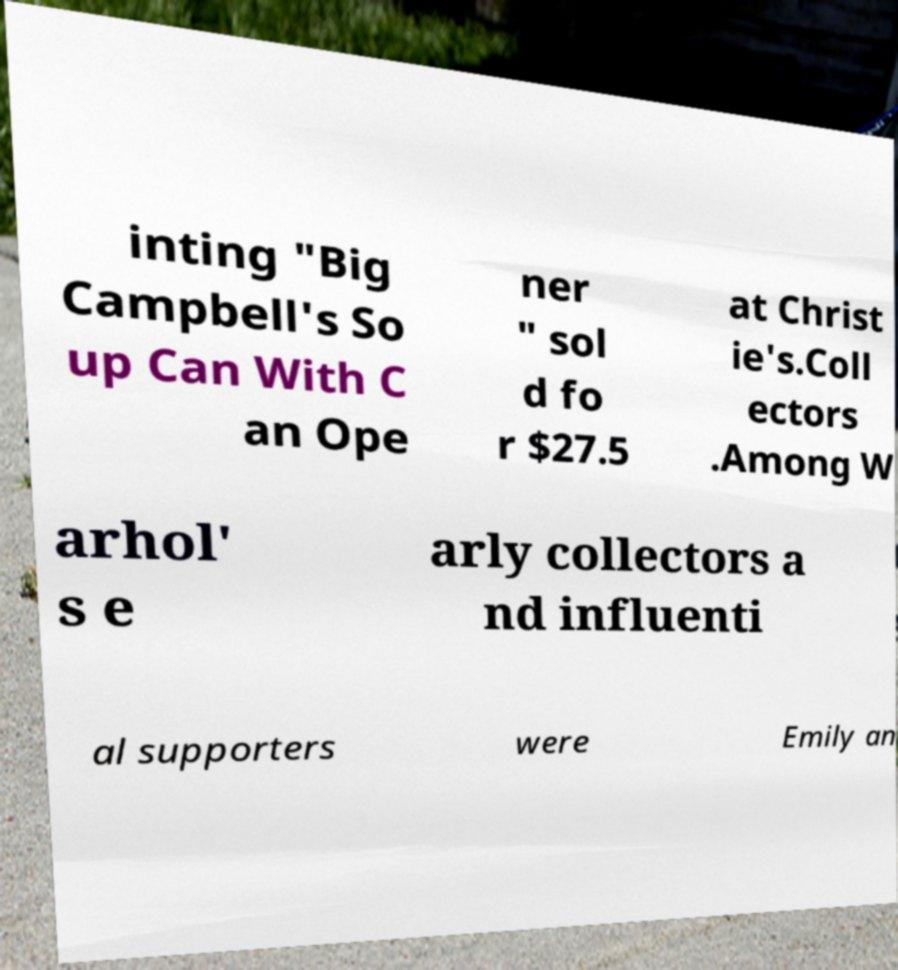There's text embedded in this image that I need extracted. Can you transcribe it verbatim? inting "Big Campbell's So up Can With C an Ope ner " sol d fo r $27.5 at Christ ie's.Coll ectors .Among W arhol' s e arly collectors a nd influenti al supporters were Emily an 